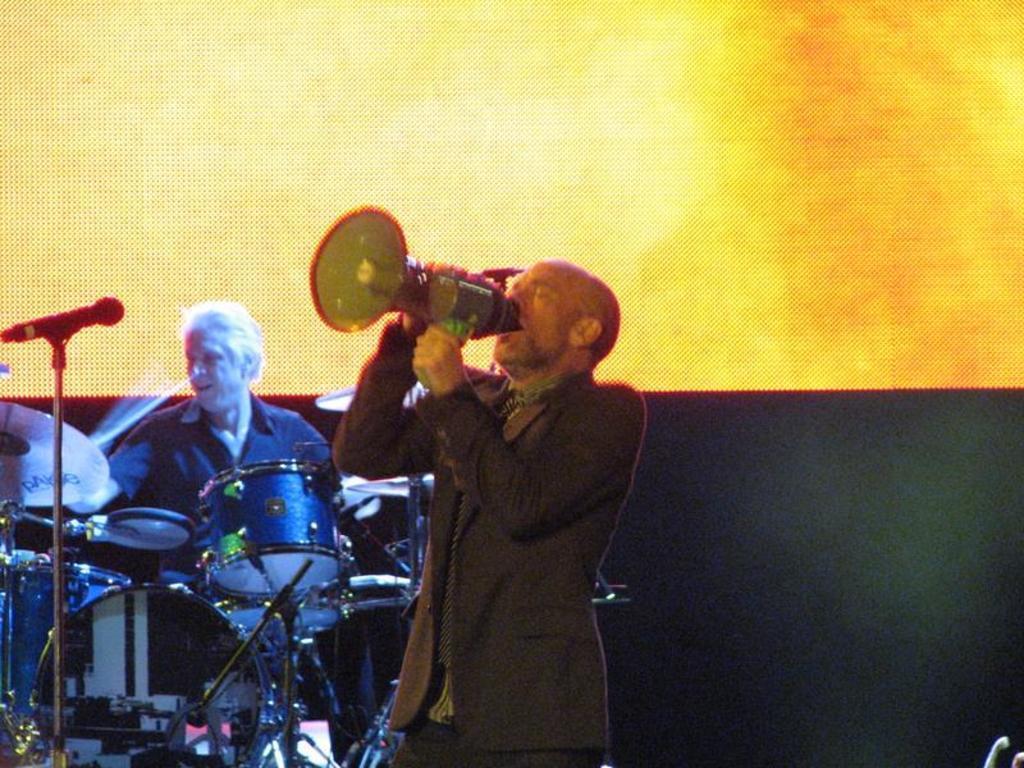In one or two sentences, can you explain what this image depicts? In this image I can see a man is holding a speaker in his hands. It is looking like he is singing a song. On the left side I can see a man is playing the drums. 